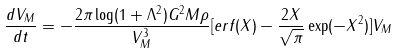Convert formula to latex. <formula><loc_0><loc_0><loc_500><loc_500>\frac { d V _ { M } } { d t } = - \frac { 2 \pi \log ( 1 + \Lambda ^ { 2 } ) G ^ { 2 } M \rho } { V _ { M } ^ { 3 } } [ e r f ( X ) - \frac { 2 X } { \sqrt { \pi } } \exp ( - X ^ { 2 } ) ] V _ { M }</formula> 